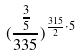Convert formula to latex. <formula><loc_0><loc_0><loc_500><loc_500>( \frac { \frac { 3 } { 5 } } { 3 3 5 } ) ^ { \frac { 3 1 5 } { 2 } \cdot 5 }</formula> 